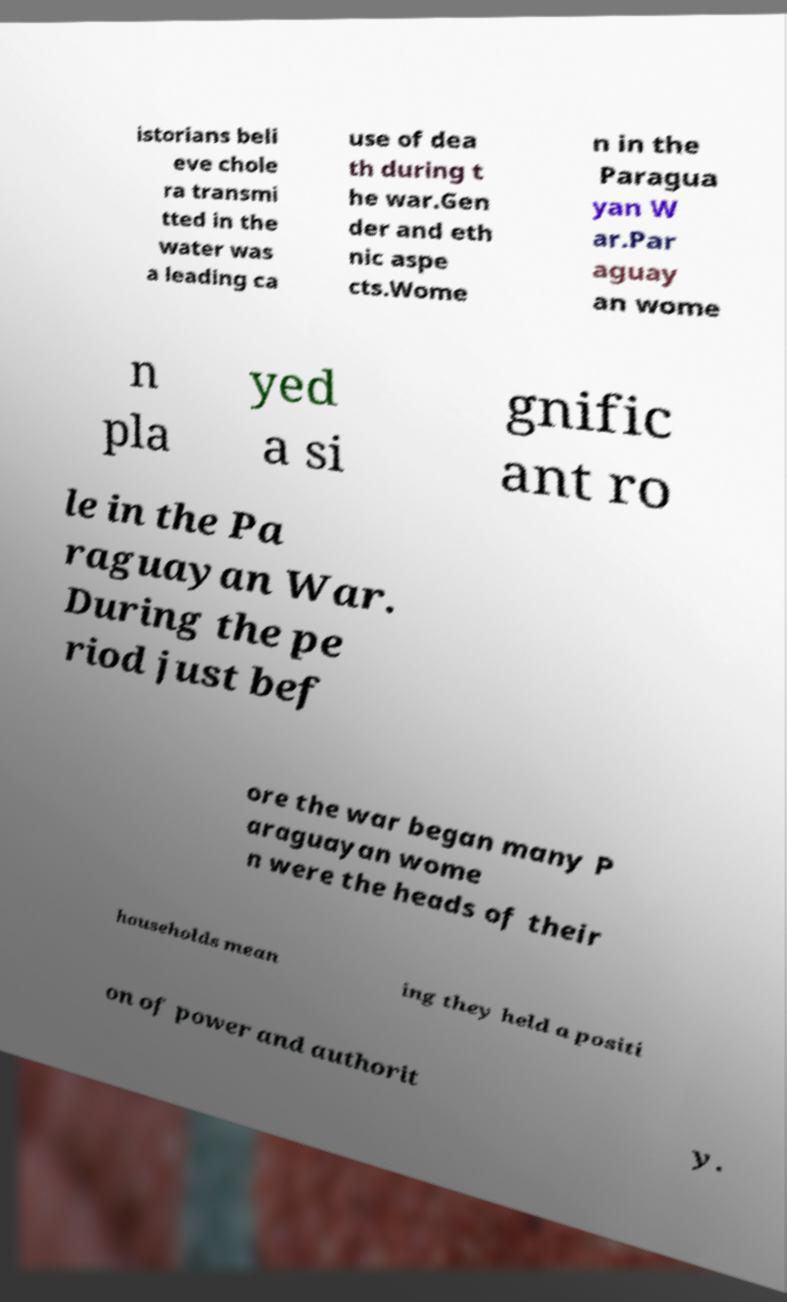Can you read and provide the text displayed in the image?This photo seems to have some interesting text. Can you extract and type it out for me? istorians beli eve chole ra transmi tted in the water was a leading ca use of dea th during t he war.Gen der and eth nic aspe cts.Wome n in the Paragua yan W ar.Par aguay an wome n pla yed a si gnific ant ro le in the Pa raguayan War. During the pe riod just bef ore the war began many P araguayan wome n were the heads of their households mean ing they held a positi on of power and authorit y. 